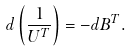Convert formula to latex. <formula><loc_0><loc_0><loc_500><loc_500>d \left ( \frac { 1 } { U ^ { T } } \right ) = - d B ^ { T } .</formula> 